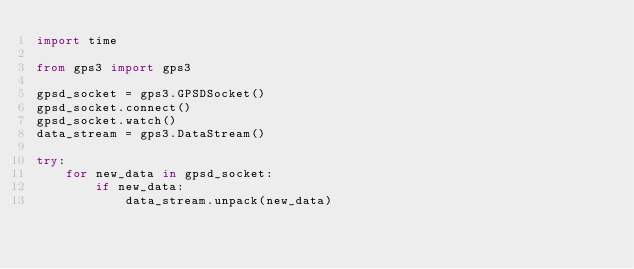<code> <loc_0><loc_0><loc_500><loc_500><_Python_>import time

from gps3 import gps3

gpsd_socket = gps3.GPSDSocket()
gpsd_socket.connect()
gpsd_socket.watch()
data_stream = gps3.DataStream()

try:
    for new_data in gpsd_socket:
        if new_data:
            data_stream.unpack(new_data)</code> 